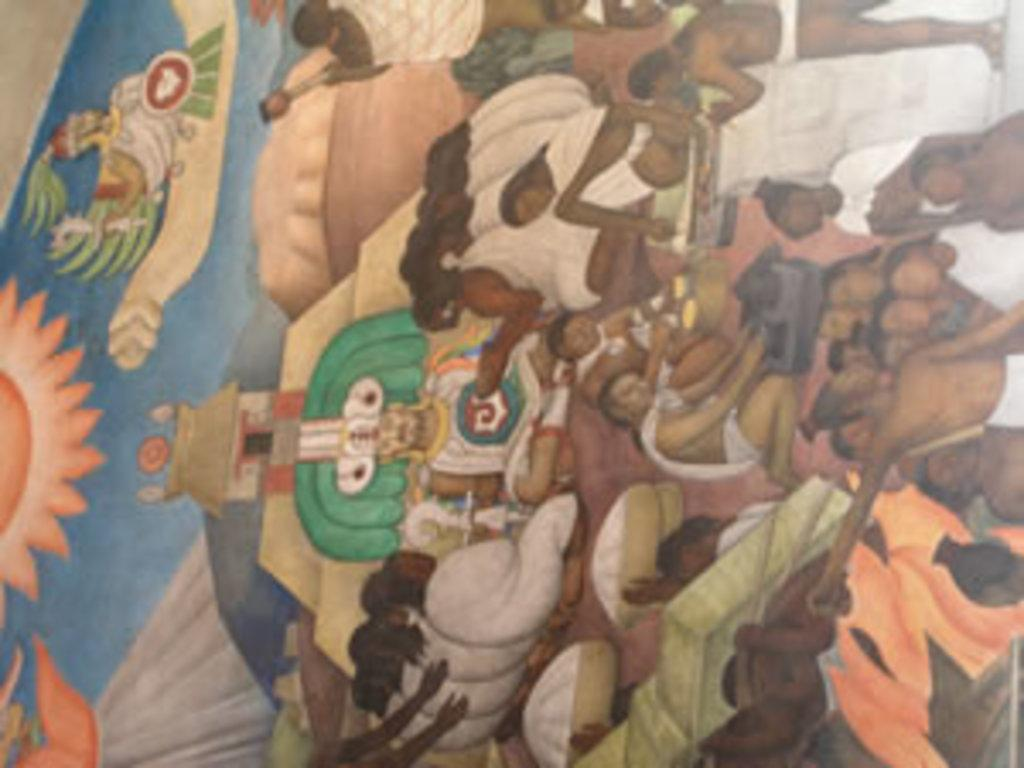What is the main subject of the image? The main subject of the image is a painting. What can be seen in the painting? The painting contains depictions of people. Where is the notebook placed in the image? There is no notebook present in the image. What type of material is the cork made of in the image? There is no cork present in the image. 